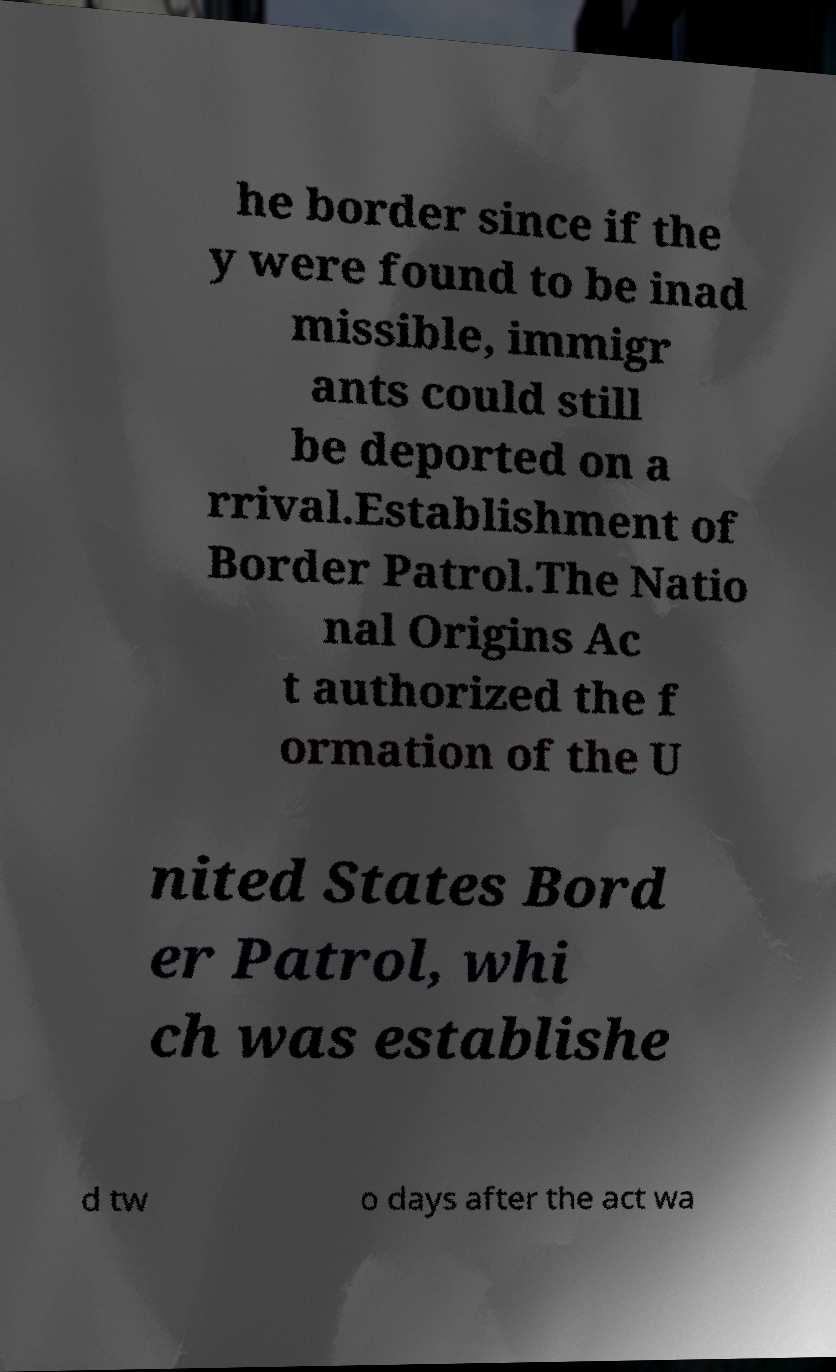Can you read and provide the text displayed in the image?This photo seems to have some interesting text. Can you extract and type it out for me? he border since if the y were found to be inad missible, immigr ants could still be deported on a rrival.Establishment of Border Patrol.The Natio nal Origins Ac t authorized the f ormation of the U nited States Bord er Patrol, whi ch was establishe d tw o days after the act wa 